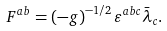<formula> <loc_0><loc_0><loc_500><loc_500>F ^ { a b } = \left ( - g \right ) ^ { - 1 / 2 } \varepsilon ^ { a b c } \bar { \lambda } _ { c } .</formula> 